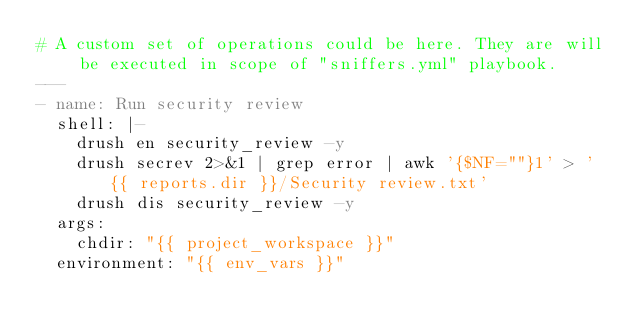<code> <loc_0><loc_0><loc_500><loc_500><_YAML_># A custom set of operations could be here. They are will be executed in scope of "sniffers.yml" playbook.
---
- name: Run security review
  shell: |-
    drush en security_review -y
    drush secrev 2>&1 | grep error | awk '{$NF=""}1' > '{{ reports.dir }}/Security review.txt'
    drush dis security_review -y
  args:
    chdir: "{{ project_workspace }}"
  environment: "{{ env_vars }}"
</code> 